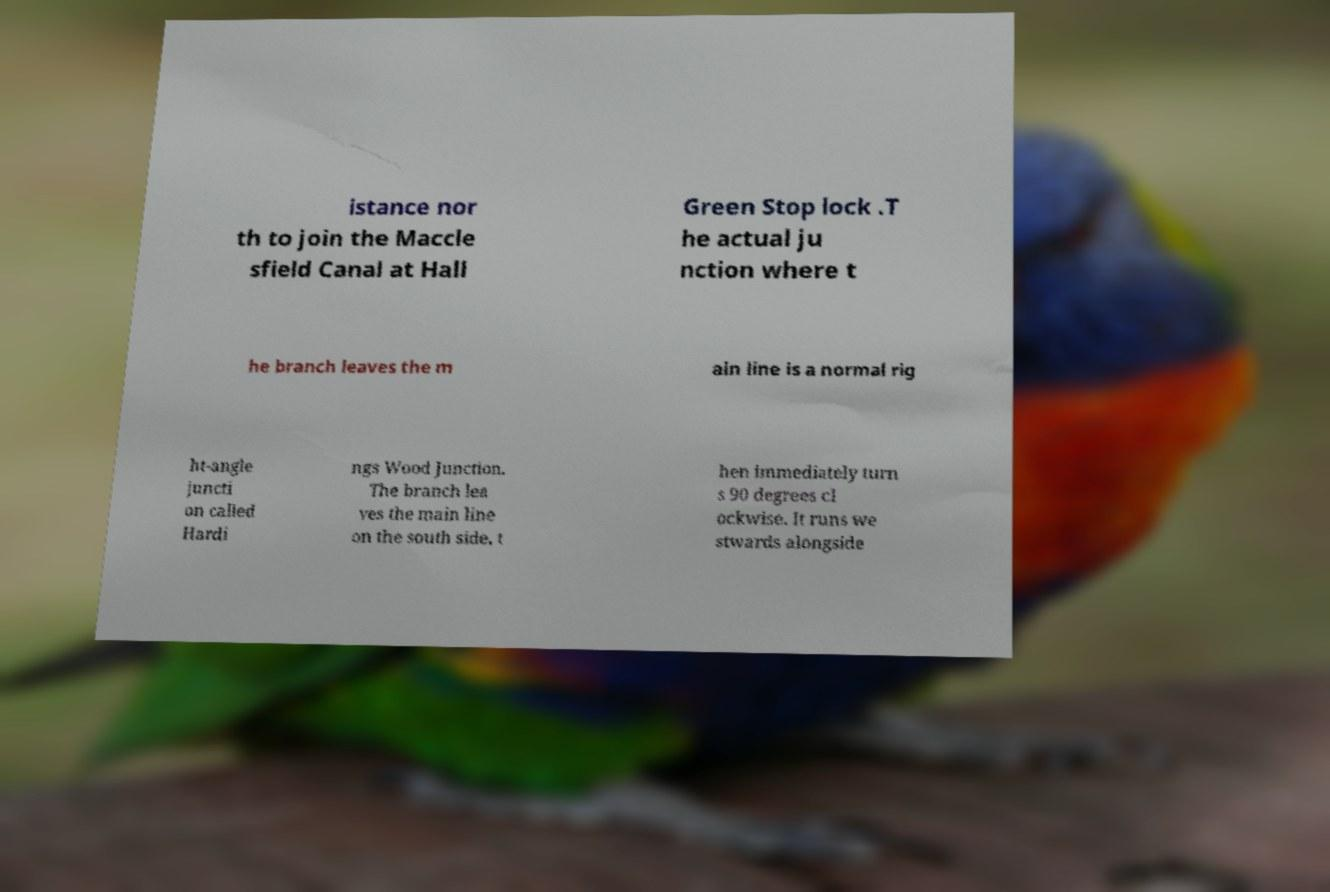Could you extract and type out the text from this image? istance nor th to join the Maccle sfield Canal at Hall Green Stop lock .T he actual ju nction where t he branch leaves the m ain line is a normal rig ht-angle juncti on called Hardi ngs Wood Junction. The branch lea ves the main line on the south side, t hen immediately turn s 90 degrees cl ockwise. It runs we stwards alongside 